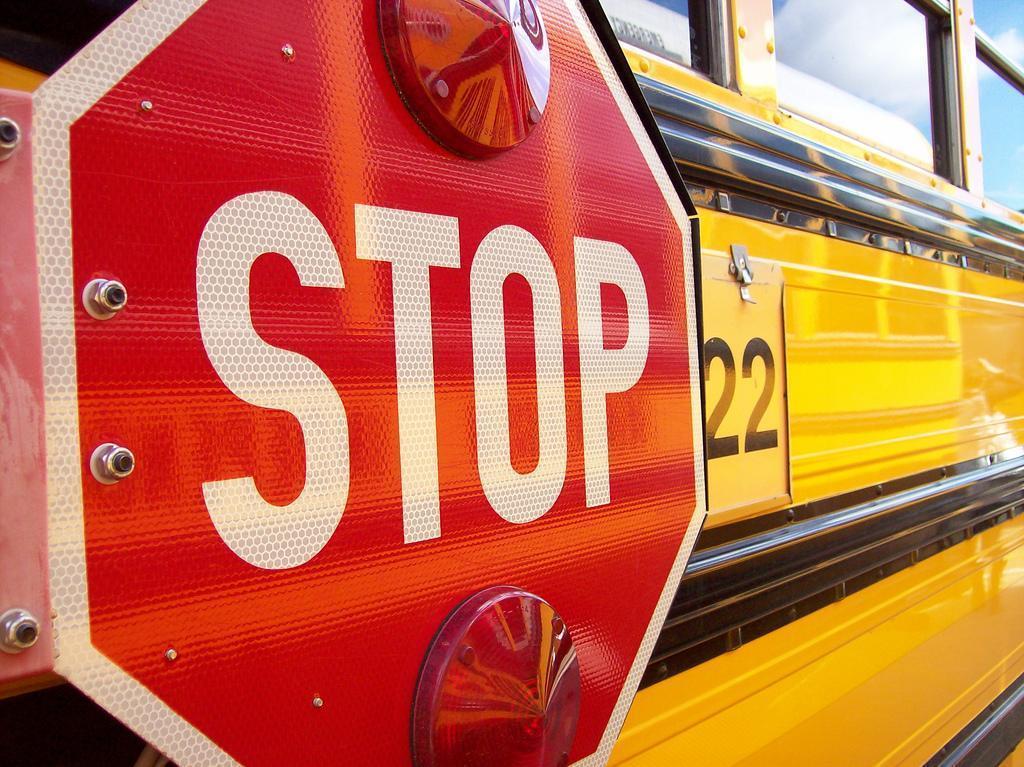How many stop signs are being shown?
Give a very brief answer. 1. How many school buses are being shown?
Give a very brief answer. 1. How many reflectors are on the sign?
Give a very brief answer. 2. How many bolts are on the stop sign?
Give a very brief answer. 2. 